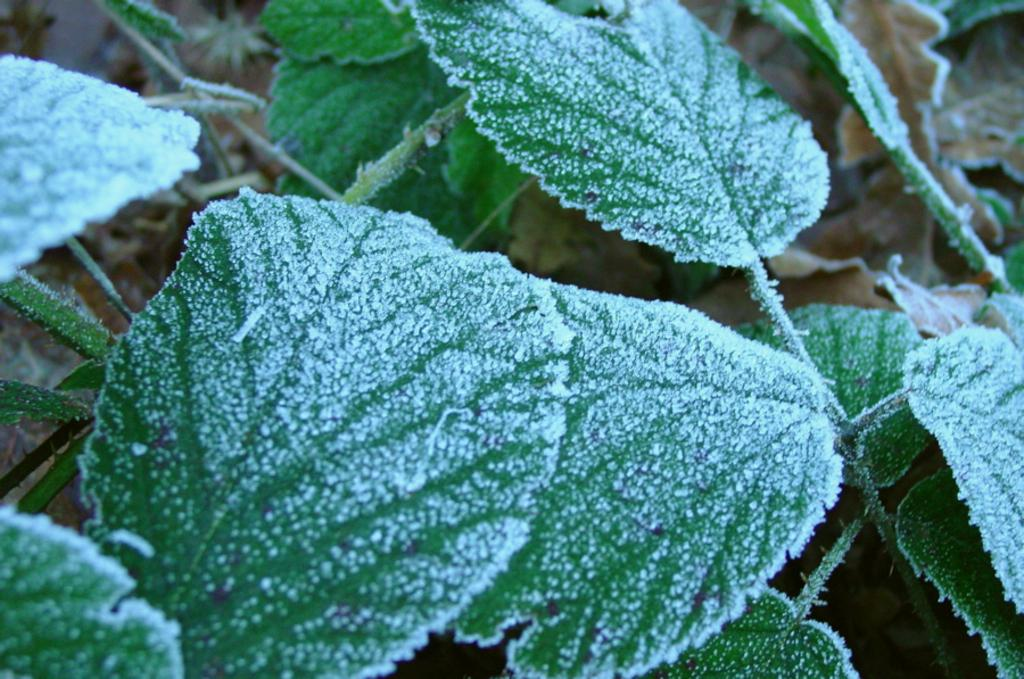What type of vegetation can be seen in the image? There are leaves in the image. What is the weather condition in the image? Snow is present on the leaves, indicating a snowy condition. What type of ray is visible in the image? There is no ray present in the image; it features leaves with snow on them. What reward is being given to the leaves in the image? There is no reward being given to the leaves in the image; they are simply covered in snow. 